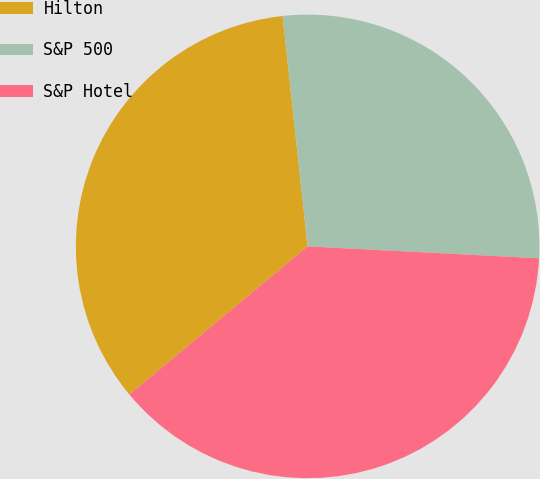Convert chart to OTSL. <chart><loc_0><loc_0><loc_500><loc_500><pie_chart><fcel>Hilton<fcel>S&P 500<fcel>S&P Hotel<nl><fcel>34.31%<fcel>27.54%<fcel>38.15%<nl></chart> 